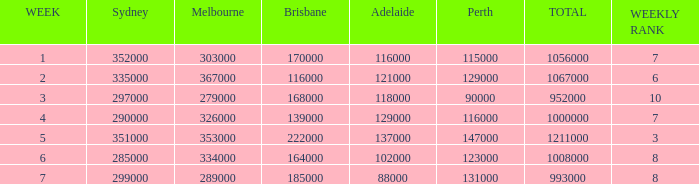What's the largest audience size in brisbane? 222000.0. 